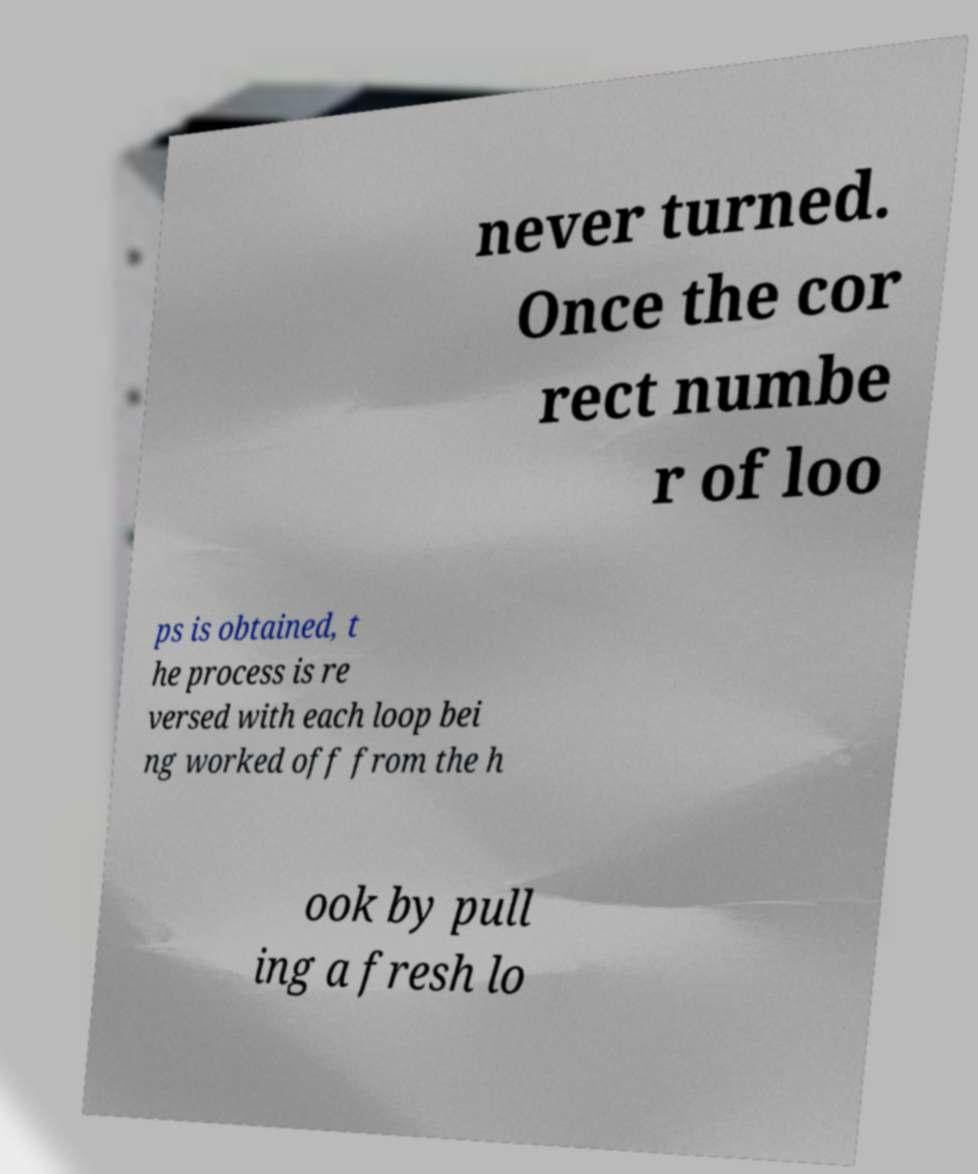Please read and relay the text visible in this image. What does it say? never turned. Once the cor rect numbe r of loo ps is obtained, t he process is re versed with each loop bei ng worked off from the h ook by pull ing a fresh lo 